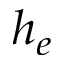<formula> <loc_0><loc_0><loc_500><loc_500>h _ { e }</formula> 